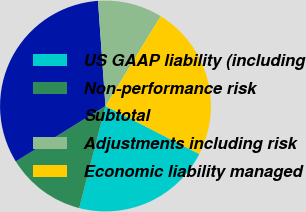Convert chart. <chart><loc_0><loc_0><loc_500><loc_500><pie_chart><fcel>US GAAP liability (including<fcel>Non-performance risk<fcel>Subtotal<fcel>Adjustments including risk<fcel>Economic liability managed<nl><fcel>21.48%<fcel>12.18%<fcel>32.68%<fcel>9.9%<fcel>23.76%<nl></chart> 